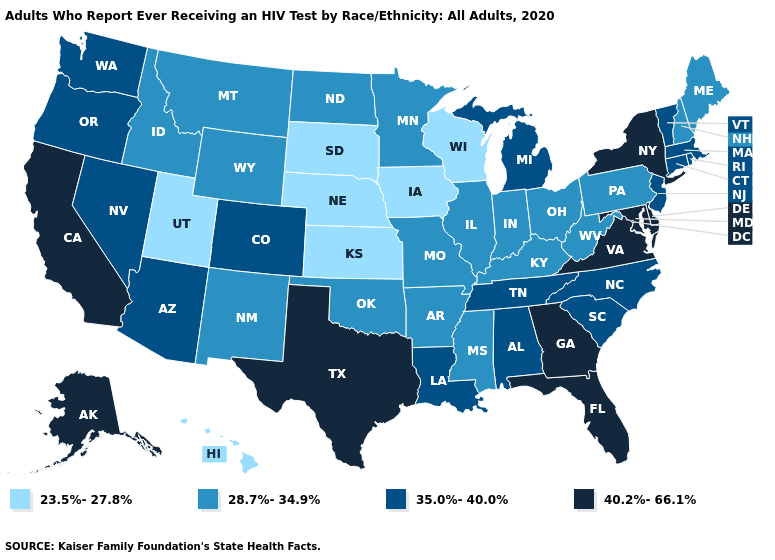Does New Mexico have a lower value than New York?
Write a very short answer. Yes. What is the value of Montana?
Answer briefly. 28.7%-34.9%. Does Arkansas have a higher value than Utah?
Give a very brief answer. Yes. Among the states that border Montana , which have the lowest value?
Keep it brief. South Dakota. Name the states that have a value in the range 23.5%-27.8%?
Keep it brief. Hawaii, Iowa, Kansas, Nebraska, South Dakota, Utah, Wisconsin. Name the states that have a value in the range 28.7%-34.9%?
Short answer required. Arkansas, Idaho, Illinois, Indiana, Kentucky, Maine, Minnesota, Mississippi, Missouri, Montana, New Hampshire, New Mexico, North Dakota, Ohio, Oklahoma, Pennsylvania, West Virginia, Wyoming. Is the legend a continuous bar?
Keep it brief. No. What is the value of Connecticut?
Write a very short answer. 35.0%-40.0%. Name the states that have a value in the range 23.5%-27.8%?
Keep it brief. Hawaii, Iowa, Kansas, Nebraska, South Dakota, Utah, Wisconsin. What is the highest value in the Northeast ?
Answer briefly. 40.2%-66.1%. Does New York have the highest value in the Northeast?
Give a very brief answer. Yes. Does Kentucky have a lower value than Pennsylvania?
Short answer required. No. Is the legend a continuous bar?
Be succinct. No. Name the states that have a value in the range 23.5%-27.8%?
Short answer required. Hawaii, Iowa, Kansas, Nebraska, South Dakota, Utah, Wisconsin. What is the lowest value in states that border South Carolina?
Quick response, please. 35.0%-40.0%. 